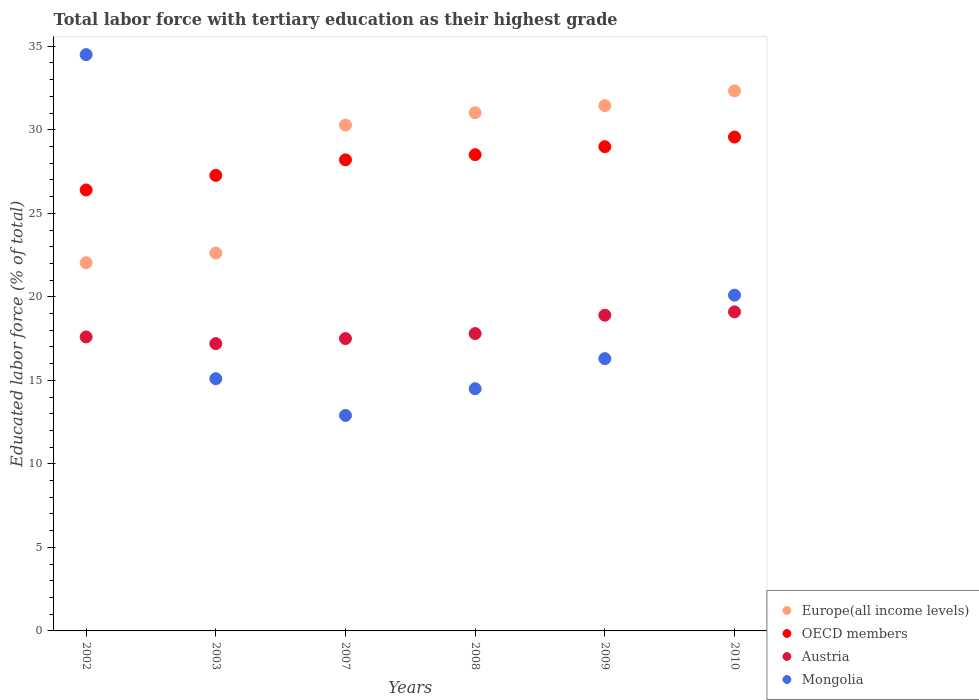What is the percentage of male labor force with tertiary education in Austria in 2002?
Ensure brevity in your answer.  17.6. Across all years, what is the maximum percentage of male labor force with tertiary education in OECD members?
Keep it short and to the point. 29.57. Across all years, what is the minimum percentage of male labor force with tertiary education in Europe(all income levels)?
Keep it short and to the point. 22.04. What is the total percentage of male labor force with tertiary education in Europe(all income levels) in the graph?
Give a very brief answer. 169.74. What is the difference between the percentage of male labor force with tertiary education in Europe(all income levels) in 2007 and that in 2008?
Your answer should be compact. -0.74. What is the difference between the percentage of male labor force with tertiary education in OECD members in 2003 and the percentage of male labor force with tertiary education in Europe(all income levels) in 2010?
Provide a short and direct response. -5.06. What is the average percentage of male labor force with tertiary education in Austria per year?
Offer a very short reply. 18.02. In the year 2003, what is the difference between the percentage of male labor force with tertiary education in OECD members and percentage of male labor force with tertiary education in Europe(all income levels)?
Ensure brevity in your answer.  4.65. In how many years, is the percentage of male labor force with tertiary education in Austria greater than 33 %?
Keep it short and to the point. 0. What is the ratio of the percentage of male labor force with tertiary education in OECD members in 2002 to that in 2009?
Provide a succinct answer. 0.91. Is the difference between the percentage of male labor force with tertiary education in OECD members in 2003 and 2008 greater than the difference between the percentage of male labor force with tertiary education in Europe(all income levels) in 2003 and 2008?
Provide a short and direct response. Yes. What is the difference between the highest and the second highest percentage of male labor force with tertiary education in OECD members?
Offer a terse response. 0.58. What is the difference between the highest and the lowest percentage of male labor force with tertiary education in Mongolia?
Offer a terse response. 21.6. Is the sum of the percentage of male labor force with tertiary education in Austria in 2003 and 2009 greater than the maximum percentage of male labor force with tertiary education in OECD members across all years?
Offer a very short reply. Yes. Is it the case that in every year, the sum of the percentage of male labor force with tertiary education in Europe(all income levels) and percentage of male labor force with tertiary education in Austria  is greater than the sum of percentage of male labor force with tertiary education in Mongolia and percentage of male labor force with tertiary education in OECD members?
Your answer should be compact. No. Is it the case that in every year, the sum of the percentage of male labor force with tertiary education in Austria and percentage of male labor force with tertiary education in Mongolia  is greater than the percentage of male labor force with tertiary education in Europe(all income levels)?
Offer a terse response. Yes. Does the percentage of male labor force with tertiary education in Austria monotonically increase over the years?
Provide a succinct answer. No. Is the percentage of male labor force with tertiary education in Europe(all income levels) strictly greater than the percentage of male labor force with tertiary education in Austria over the years?
Ensure brevity in your answer.  Yes. How many dotlines are there?
Offer a terse response. 4. What is the difference between two consecutive major ticks on the Y-axis?
Keep it short and to the point. 5. Does the graph contain grids?
Ensure brevity in your answer.  No. How are the legend labels stacked?
Ensure brevity in your answer.  Vertical. What is the title of the graph?
Make the answer very short. Total labor force with tertiary education as their highest grade. What is the label or title of the Y-axis?
Ensure brevity in your answer.  Educated labor force (% of total). What is the Educated labor force (% of total) of Europe(all income levels) in 2002?
Your answer should be very brief. 22.04. What is the Educated labor force (% of total) in OECD members in 2002?
Your answer should be compact. 26.4. What is the Educated labor force (% of total) in Austria in 2002?
Your response must be concise. 17.6. What is the Educated labor force (% of total) of Mongolia in 2002?
Your response must be concise. 34.5. What is the Educated labor force (% of total) in Europe(all income levels) in 2003?
Keep it short and to the point. 22.62. What is the Educated labor force (% of total) in OECD members in 2003?
Provide a succinct answer. 27.27. What is the Educated labor force (% of total) of Austria in 2003?
Make the answer very short. 17.2. What is the Educated labor force (% of total) of Mongolia in 2003?
Your answer should be very brief. 15.1. What is the Educated labor force (% of total) of Europe(all income levels) in 2007?
Ensure brevity in your answer.  30.28. What is the Educated labor force (% of total) of OECD members in 2007?
Your answer should be very brief. 28.2. What is the Educated labor force (% of total) of Mongolia in 2007?
Your answer should be compact. 12.9. What is the Educated labor force (% of total) of Europe(all income levels) in 2008?
Provide a succinct answer. 31.02. What is the Educated labor force (% of total) in OECD members in 2008?
Ensure brevity in your answer.  28.51. What is the Educated labor force (% of total) of Austria in 2008?
Make the answer very short. 17.8. What is the Educated labor force (% of total) of Mongolia in 2008?
Keep it short and to the point. 14.5. What is the Educated labor force (% of total) in Europe(all income levels) in 2009?
Offer a terse response. 31.45. What is the Educated labor force (% of total) of OECD members in 2009?
Provide a short and direct response. 28.99. What is the Educated labor force (% of total) in Austria in 2009?
Provide a short and direct response. 18.9. What is the Educated labor force (% of total) of Mongolia in 2009?
Your response must be concise. 16.3. What is the Educated labor force (% of total) of Europe(all income levels) in 2010?
Keep it short and to the point. 32.33. What is the Educated labor force (% of total) of OECD members in 2010?
Give a very brief answer. 29.57. What is the Educated labor force (% of total) of Austria in 2010?
Provide a short and direct response. 19.1. What is the Educated labor force (% of total) in Mongolia in 2010?
Your answer should be compact. 20.1. Across all years, what is the maximum Educated labor force (% of total) in Europe(all income levels)?
Your answer should be compact. 32.33. Across all years, what is the maximum Educated labor force (% of total) in OECD members?
Your answer should be compact. 29.57. Across all years, what is the maximum Educated labor force (% of total) in Austria?
Ensure brevity in your answer.  19.1. Across all years, what is the maximum Educated labor force (% of total) in Mongolia?
Ensure brevity in your answer.  34.5. Across all years, what is the minimum Educated labor force (% of total) of Europe(all income levels)?
Your response must be concise. 22.04. Across all years, what is the minimum Educated labor force (% of total) in OECD members?
Ensure brevity in your answer.  26.4. Across all years, what is the minimum Educated labor force (% of total) of Austria?
Offer a very short reply. 17.2. Across all years, what is the minimum Educated labor force (% of total) of Mongolia?
Provide a succinct answer. 12.9. What is the total Educated labor force (% of total) of Europe(all income levels) in the graph?
Your answer should be compact. 169.74. What is the total Educated labor force (% of total) of OECD members in the graph?
Provide a short and direct response. 168.93. What is the total Educated labor force (% of total) in Austria in the graph?
Provide a succinct answer. 108.1. What is the total Educated labor force (% of total) in Mongolia in the graph?
Give a very brief answer. 113.4. What is the difference between the Educated labor force (% of total) of Europe(all income levels) in 2002 and that in 2003?
Your answer should be compact. -0.58. What is the difference between the Educated labor force (% of total) in OECD members in 2002 and that in 2003?
Your answer should be compact. -0.87. What is the difference between the Educated labor force (% of total) of Europe(all income levels) in 2002 and that in 2007?
Your answer should be compact. -8.24. What is the difference between the Educated labor force (% of total) in OECD members in 2002 and that in 2007?
Ensure brevity in your answer.  -1.8. What is the difference between the Educated labor force (% of total) in Mongolia in 2002 and that in 2007?
Provide a short and direct response. 21.6. What is the difference between the Educated labor force (% of total) in Europe(all income levels) in 2002 and that in 2008?
Your response must be concise. -8.98. What is the difference between the Educated labor force (% of total) in OECD members in 2002 and that in 2008?
Your answer should be compact. -2.11. What is the difference between the Educated labor force (% of total) of Europe(all income levels) in 2002 and that in 2009?
Ensure brevity in your answer.  -9.4. What is the difference between the Educated labor force (% of total) in OECD members in 2002 and that in 2009?
Your answer should be very brief. -2.59. What is the difference between the Educated labor force (% of total) in Mongolia in 2002 and that in 2009?
Give a very brief answer. 18.2. What is the difference between the Educated labor force (% of total) of Europe(all income levels) in 2002 and that in 2010?
Provide a short and direct response. -10.28. What is the difference between the Educated labor force (% of total) of OECD members in 2002 and that in 2010?
Keep it short and to the point. -3.17. What is the difference between the Educated labor force (% of total) in Austria in 2002 and that in 2010?
Make the answer very short. -1.5. What is the difference between the Educated labor force (% of total) in Mongolia in 2002 and that in 2010?
Give a very brief answer. 14.4. What is the difference between the Educated labor force (% of total) of Europe(all income levels) in 2003 and that in 2007?
Provide a short and direct response. -7.66. What is the difference between the Educated labor force (% of total) in OECD members in 2003 and that in 2007?
Your answer should be very brief. -0.93. What is the difference between the Educated labor force (% of total) of Mongolia in 2003 and that in 2007?
Your answer should be compact. 2.2. What is the difference between the Educated labor force (% of total) of Europe(all income levels) in 2003 and that in 2008?
Give a very brief answer. -8.4. What is the difference between the Educated labor force (% of total) in OECD members in 2003 and that in 2008?
Give a very brief answer. -1.24. What is the difference between the Educated labor force (% of total) in Mongolia in 2003 and that in 2008?
Keep it short and to the point. 0.6. What is the difference between the Educated labor force (% of total) in Europe(all income levels) in 2003 and that in 2009?
Make the answer very short. -8.82. What is the difference between the Educated labor force (% of total) in OECD members in 2003 and that in 2009?
Your answer should be very brief. -1.72. What is the difference between the Educated labor force (% of total) in Austria in 2003 and that in 2009?
Offer a terse response. -1.7. What is the difference between the Educated labor force (% of total) in Mongolia in 2003 and that in 2009?
Keep it short and to the point. -1.2. What is the difference between the Educated labor force (% of total) in Europe(all income levels) in 2003 and that in 2010?
Keep it short and to the point. -9.7. What is the difference between the Educated labor force (% of total) in OECD members in 2003 and that in 2010?
Offer a terse response. -2.29. What is the difference between the Educated labor force (% of total) in Mongolia in 2003 and that in 2010?
Offer a very short reply. -5. What is the difference between the Educated labor force (% of total) of Europe(all income levels) in 2007 and that in 2008?
Provide a short and direct response. -0.74. What is the difference between the Educated labor force (% of total) of OECD members in 2007 and that in 2008?
Provide a short and direct response. -0.31. What is the difference between the Educated labor force (% of total) of Mongolia in 2007 and that in 2008?
Provide a succinct answer. -1.6. What is the difference between the Educated labor force (% of total) of Europe(all income levels) in 2007 and that in 2009?
Offer a terse response. -1.16. What is the difference between the Educated labor force (% of total) in OECD members in 2007 and that in 2009?
Keep it short and to the point. -0.79. What is the difference between the Educated labor force (% of total) of Austria in 2007 and that in 2009?
Provide a short and direct response. -1.4. What is the difference between the Educated labor force (% of total) in Mongolia in 2007 and that in 2009?
Your response must be concise. -3.4. What is the difference between the Educated labor force (% of total) in Europe(all income levels) in 2007 and that in 2010?
Your answer should be very brief. -2.04. What is the difference between the Educated labor force (% of total) of OECD members in 2007 and that in 2010?
Give a very brief answer. -1.36. What is the difference between the Educated labor force (% of total) of Europe(all income levels) in 2008 and that in 2009?
Offer a very short reply. -0.43. What is the difference between the Educated labor force (% of total) of OECD members in 2008 and that in 2009?
Your answer should be very brief. -0.48. What is the difference between the Educated labor force (% of total) of Mongolia in 2008 and that in 2009?
Keep it short and to the point. -1.8. What is the difference between the Educated labor force (% of total) in Europe(all income levels) in 2008 and that in 2010?
Your response must be concise. -1.31. What is the difference between the Educated labor force (% of total) in OECD members in 2008 and that in 2010?
Your answer should be compact. -1.06. What is the difference between the Educated labor force (% of total) of Europe(all income levels) in 2009 and that in 2010?
Your answer should be very brief. -0.88. What is the difference between the Educated labor force (% of total) in OECD members in 2009 and that in 2010?
Keep it short and to the point. -0.58. What is the difference between the Educated labor force (% of total) in Austria in 2009 and that in 2010?
Offer a very short reply. -0.2. What is the difference between the Educated labor force (% of total) in Europe(all income levels) in 2002 and the Educated labor force (% of total) in OECD members in 2003?
Provide a succinct answer. -5.23. What is the difference between the Educated labor force (% of total) in Europe(all income levels) in 2002 and the Educated labor force (% of total) in Austria in 2003?
Offer a terse response. 4.84. What is the difference between the Educated labor force (% of total) of Europe(all income levels) in 2002 and the Educated labor force (% of total) of Mongolia in 2003?
Give a very brief answer. 6.94. What is the difference between the Educated labor force (% of total) in OECD members in 2002 and the Educated labor force (% of total) in Austria in 2003?
Offer a very short reply. 9.2. What is the difference between the Educated labor force (% of total) of OECD members in 2002 and the Educated labor force (% of total) of Mongolia in 2003?
Provide a short and direct response. 11.3. What is the difference between the Educated labor force (% of total) in Europe(all income levels) in 2002 and the Educated labor force (% of total) in OECD members in 2007?
Your answer should be compact. -6.16. What is the difference between the Educated labor force (% of total) in Europe(all income levels) in 2002 and the Educated labor force (% of total) in Austria in 2007?
Provide a short and direct response. 4.54. What is the difference between the Educated labor force (% of total) in Europe(all income levels) in 2002 and the Educated labor force (% of total) in Mongolia in 2007?
Give a very brief answer. 9.14. What is the difference between the Educated labor force (% of total) in OECD members in 2002 and the Educated labor force (% of total) in Austria in 2007?
Make the answer very short. 8.9. What is the difference between the Educated labor force (% of total) in OECD members in 2002 and the Educated labor force (% of total) in Mongolia in 2007?
Give a very brief answer. 13.5. What is the difference between the Educated labor force (% of total) of Austria in 2002 and the Educated labor force (% of total) of Mongolia in 2007?
Keep it short and to the point. 4.7. What is the difference between the Educated labor force (% of total) of Europe(all income levels) in 2002 and the Educated labor force (% of total) of OECD members in 2008?
Provide a short and direct response. -6.47. What is the difference between the Educated labor force (% of total) of Europe(all income levels) in 2002 and the Educated labor force (% of total) of Austria in 2008?
Your answer should be very brief. 4.24. What is the difference between the Educated labor force (% of total) in Europe(all income levels) in 2002 and the Educated labor force (% of total) in Mongolia in 2008?
Ensure brevity in your answer.  7.54. What is the difference between the Educated labor force (% of total) in OECD members in 2002 and the Educated labor force (% of total) in Austria in 2008?
Your response must be concise. 8.6. What is the difference between the Educated labor force (% of total) of OECD members in 2002 and the Educated labor force (% of total) of Mongolia in 2008?
Keep it short and to the point. 11.9. What is the difference between the Educated labor force (% of total) in Europe(all income levels) in 2002 and the Educated labor force (% of total) in OECD members in 2009?
Provide a short and direct response. -6.95. What is the difference between the Educated labor force (% of total) of Europe(all income levels) in 2002 and the Educated labor force (% of total) of Austria in 2009?
Your answer should be very brief. 3.14. What is the difference between the Educated labor force (% of total) of Europe(all income levels) in 2002 and the Educated labor force (% of total) of Mongolia in 2009?
Your response must be concise. 5.74. What is the difference between the Educated labor force (% of total) of OECD members in 2002 and the Educated labor force (% of total) of Austria in 2009?
Keep it short and to the point. 7.5. What is the difference between the Educated labor force (% of total) in OECD members in 2002 and the Educated labor force (% of total) in Mongolia in 2009?
Make the answer very short. 10.1. What is the difference between the Educated labor force (% of total) of Austria in 2002 and the Educated labor force (% of total) of Mongolia in 2009?
Provide a succinct answer. 1.3. What is the difference between the Educated labor force (% of total) in Europe(all income levels) in 2002 and the Educated labor force (% of total) in OECD members in 2010?
Give a very brief answer. -7.52. What is the difference between the Educated labor force (% of total) in Europe(all income levels) in 2002 and the Educated labor force (% of total) in Austria in 2010?
Offer a very short reply. 2.94. What is the difference between the Educated labor force (% of total) in Europe(all income levels) in 2002 and the Educated labor force (% of total) in Mongolia in 2010?
Offer a terse response. 1.94. What is the difference between the Educated labor force (% of total) of OECD members in 2002 and the Educated labor force (% of total) of Austria in 2010?
Give a very brief answer. 7.3. What is the difference between the Educated labor force (% of total) of OECD members in 2002 and the Educated labor force (% of total) of Mongolia in 2010?
Your answer should be compact. 6.3. What is the difference between the Educated labor force (% of total) of Europe(all income levels) in 2003 and the Educated labor force (% of total) of OECD members in 2007?
Provide a succinct answer. -5.58. What is the difference between the Educated labor force (% of total) of Europe(all income levels) in 2003 and the Educated labor force (% of total) of Austria in 2007?
Your answer should be compact. 5.12. What is the difference between the Educated labor force (% of total) of Europe(all income levels) in 2003 and the Educated labor force (% of total) of Mongolia in 2007?
Keep it short and to the point. 9.72. What is the difference between the Educated labor force (% of total) in OECD members in 2003 and the Educated labor force (% of total) in Austria in 2007?
Your response must be concise. 9.77. What is the difference between the Educated labor force (% of total) of OECD members in 2003 and the Educated labor force (% of total) of Mongolia in 2007?
Provide a succinct answer. 14.37. What is the difference between the Educated labor force (% of total) in Europe(all income levels) in 2003 and the Educated labor force (% of total) in OECD members in 2008?
Your answer should be very brief. -5.89. What is the difference between the Educated labor force (% of total) of Europe(all income levels) in 2003 and the Educated labor force (% of total) of Austria in 2008?
Keep it short and to the point. 4.82. What is the difference between the Educated labor force (% of total) of Europe(all income levels) in 2003 and the Educated labor force (% of total) of Mongolia in 2008?
Provide a succinct answer. 8.12. What is the difference between the Educated labor force (% of total) of OECD members in 2003 and the Educated labor force (% of total) of Austria in 2008?
Offer a terse response. 9.47. What is the difference between the Educated labor force (% of total) of OECD members in 2003 and the Educated labor force (% of total) of Mongolia in 2008?
Provide a short and direct response. 12.77. What is the difference between the Educated labor force (% of total) of Europe(all income levels) in 2003 and the Educated labor force (% of total) of OECD members in 2009?
Offer a very short reply. -6.37. What is the difference between the Educated labor force (% of total) in Europe(all income levels) in 2003 and the Educated labor force (% of total) in Austria in 2009?
Your answer should be very brief. 3.72. What is the difference between the Educated labor force (% of total) in Europe(all income levels) in 2003 and the Educated labor force (% of total) in Mongolia in 2009?
Your answer should be very brief. 6.32. What is the difference between the Educated labor force (% of total) in OECD members in 2003 and the Educated labor force (% of total) in Austria in 2009?
Ensure brevity in your answer.  8.37. What is the difference between the Educated labor force (% of total) in OECD members in 2003 and the Educated labor force (% of total) in Mongolia in 2009?
Ensure brevity in your answer.  10.97. What is the difference between the Educated labor force (% of total) in Europe(all income levels) in 2003 and the Educated labor force (% of total) in OECD members in 2010?
Your answer should be very brief. -6.94. What is the difference between the Educated labor force (% of total) in Europe(all income levels) in 2003 and the Educated labor force (% of total) in Austria in 2010?
Make the answer very short. 3.52. What is the difference between the Educated labor force (% of total) of Europe(all income levels) in 2003 and the Educated labor force (% of total) of Mongolia in 2010?
Keep it short and to the point. 2.52. What is the difference between the Educated labor force (% of total) of OECD members in 2003 and the Educated labor force (% of total) of Austria in 2010?
Your answer should be very brief. 8.17. What is the difference between the Educated labor force (% of total) of OECD members in 2003 and the Educated labor force (% of total) of Mongolia in 2010?
Your answer should be very brief. 7.17. What is the difference between the Educated labor force (% of total) of Austria in 2003 and the Educated labor force (% of total) of Mongolia in 2010?
Keep it short and to the point. -2.9. What is the difference between the Educated labor force (% of total) in Europe(all income levels) in 2007 and the Educated labor force (% of total) in OECD members in 2008?
Provide a short and direct response. 1.77. What is the difference between the Educated labor force (% of total) of Europe(all income levels) in 2007 and the Educated labor force (% of total) of Austria in 2008?
Your answer should be very brief. 12.48. What is the difference between the Educated labor force (% of total) in Europe(all income levels) in 2007 and the Educated labor force (% of total) in Mongolia in 2008?
Ensure brevity in your answer.  15.78. What is the difference between the Educated labor force (% of total) in OECD members in 2007 and the Educated labor force (% of total) in Austria in 2008?
Ensure brevity in your answer.  10.4. What is the difference between the Educated labor force (% of total) in OECD members in 2007 and the Educated labor force (% of total) in Mongolia in 2008?
Your answer should be compact. 13.7. What is the difference between the Educated labor force (% of total) in Austria in 2007 and the Educated labor force (% of total) in Mongolia in 2008?
Your response must be concise. 3. What is the difference between the Educated labor force (% of total) in Europe(all income levels) in 2007 and the Educated labor force (% of total) in OECD members in 2009?
Your answer should be very brief. 1.29. What is the difference between the Educated labor force (% of total) of Europe(all income levels) in 2007 and the Educated labor force (% of total) of Austria in 2009?
Ensure brevity in your answer.  11.38. What is the difference between the Educated labor force (% of total) of Europe(all income levels) in 2007 and the Educated labor force (% of total) of Mongolia in 2009?
Give a very brief answer. 13.98. What is the difference between the Educated labor force (% of total) of OECD members in 2007 and the Educated labor force (% of total) of Austria in 2009?
Make the answer very short. 9.3. What is the difference between the Educated labor force (% of total) of OECD members in 2007 and the Educated labor force (% of total) of Mongolia in 2009?
Give a very brief answer. 11.9. What is the difference between the Educated labor force (% of total) of Austria in 2007 and the Educated labor force (% of total) of Mongolia in 2009?
Offer a very short reply. 1.2. What is the difference between the Educated labor force (% of total) of Europe(all income levels) in 2007 and the Educated labor force (% of total) of OECD members in 2010?
Keep it short and to the point. 0.72. What is the difference between the Educated labor force (% of total) of Europe(all income levels) in 2007 and the Educated labor force (% of total) of Austria in 2010?
Keep it short and to the point. 11.18. What is the difference between the Educated labor force (% of total) in Europe(all income levels) in 2007 and the Educated labor force (% of total) in Mongolia in 2010?
Provide a short and direct response. 10.18. What is the difference between the Educated labor force (% of total) of OECD members in 2007 and the Educated labor force (% of total) of Austria in 2010?
Provide a succinct answer. 9.1. What is the difference between the Educated labor force (% of total) in OECD members in 2007 and the Educated labor force (% of total) in Mongolia in 2010?
Provide a short and direct response. 8.1. What is the difference between the Educated labor force (% of total) in Europe(all income levels) in 2008 and the Educated labor force (% of total) in OECD members in 2009?
Provide a succinct answer. 2.03. What is the difference between the Educated labor force (% of total) of Europe(all income levels) in 2008 and the Educated labor force (% of total) of Austria in 2009?
Your answer should be compact. 12.12. What is the difference between the Educated labor force (% of total) in Europe(all income levels) in 2008 and the Educated labor force (% of total) in Mongolia in 2009?
Provide a short and direct response. 14.72. What is the difference between the Educated labor force (% of total) of OECD members in 2008 and the Educated labor force (% of total) of Austria in 2009?
Give a very brief answer. 9.61. What is the difference between the Educated labor force (% of total) in OECD members in 2008 and the Educated labor force (% of total) in Mongolia in 2009?
Your answer should be very brief. 12.21. What is the difference between the Educated labor force (% of total) in Europe(all income levels) in 2008 and the Educated labor force (% of total) in OECD members in 2010?
Make the answer very short. 1.45. What is the difference between the Educated labor force (% of total) of Europe(all income levels) in 2008 and the Educated labor force (% of total) of Austria in 2010?
Ensure brevity in your answer.  11.92. What is the difference between the Educated labor force (% of total) in Europe(all income levels) in 2008 and the Educated labor force (% of total) in Mongolia in 2010?
Your answer should be compact. 10.92. What is the difference between the Educated labor force (% of total) in OECD members in 2008 and the Educated labor force (% of total) in Austria in 2010?
Provide a short and direct response. 9.41. What is the difference between the Educated labor force (% of total) in OECD members in 2008 and the Educated labor force (% of total) in Mongolia in 2010?
Offer a terse response. 8.41. What is the difference between the Educated labor force (% of total) in Austria in 2008 and the Educated labor force (% of total) in Mongolia in 2010?
Make the answer very short. -2.3. What is the difference between the Educated labor force (% of total) in Europe(all income levels) in 2009 and the Educated labor force (% of total) in OECD members in 2010?
Offer a terse response. 1.88. What is the difference between the Educated labor force (% of total) of Europe(all income levels) in 2009 and the Educated labor force (% of total) of Austria in 2010?
Give a very brief answer. 12.35. What is the difference between the Educated labor force (% of total) of Europe(all income levels) in 2009 and the Educated labor force (% of total) of Mongolia in 2010?
Offer a very short reply. 11.35. What is the difference between the Educated labor force (% of total) in OECD members in 2009 and the Educated labor force (% of total) in Austria in 2010?
Keep it short and to the point. 9.89. What is the difference between the Educated labor force (% of total) in OECD members in 2009 and the Educated labor force (% of total) in Mongolia in 2010?
Offer a very short reply. 8.89. What is the difference between the Educated labor force (% of total) of Austria in 2009 and the Educated labor force (% of total) of Mongolia in 2010?
Provide a short and direct response. -1.2. What is the average Educated labor force (% of total) of Europe(all income levels) per year?
Provide a succinct answer. 28.29. What is the average Educated labor force (% of total) of OECD members per year?
Offer a very short reply. 28.16. What is the average Educated labor force (% of total) of Austria per year?
Offer a terse response. 18.02. What is the average Educated labor force (% of total) of Mongolia per year?
Provide a succinct answer. 18.9. In the year 2002, what is the difference between the Educated labor force (% of total) of Europe(all income levels) and Educated labor force (% of total) of OECD members?
Provide a succinct answer. -4.35. In the year 2002, what is the difference between the Educated labor force (% of total) of Europe(all income levels) and Educated labor force (% of total) of Austria?
Your answer should be very brief. 4.44. In the year 2002, what is the difference between the Educated labor force (% of total) in Europe(all income levels) and Educated labor force (% of total) in Mongolia?
Ensure brevity in your answer.  -12.46. In the year 2002, what is the difference between the Educated labor force (% of total) of OECD members and Educated labor force (% of total) of Austria?
Your response must be concise. 8.8. In the year 2002, what is the difference between the Educated labor force (% of total) in OECD members and Educated labor force (% of total) in Mongolia?
Your answer should be very brief. -8.1. In the year 2002, what is the difference between the Educated labor force (% of total) in Austria and Educated labor force (% of total) in Mongolia?
Your answer should be very brief. -16.9. In the year 2003, what is the difference between the Educated labor force (% of total) of Europe(all income levels) and Educated labor force (% of total) of OECD members?
Offer a terse response. -4.65. In the year 2003, what is the difference between the Educated labor force (% of total) in Europe(all income levels) and Educated labor force (% of total) in Austria?
Your answer should be compact. 5.42. In the year 2003, what is the difference between the Educated labor force (% of total) of Europe(all income levels) and Educated labor force (% of total) of Mongolia?
Your answer should be compact. 7.52. In the year 2003, what is the difference between the Educated labor force (% of total) of OECD members and Educated labor force (% of total) of Austria?
Your answer should be very brief. 10.07. In the year 2003, what is the difference between the Educated labor force (% of total) of OECD members and Educated labor force (% of total) of Mongolia?
Provide a succinct answer. 12.17. In the year 2003, what is the difference between the Educated labor force (% of total) of Austria and Educated labor force (% of total) of Mongolia?
Your answer should be compact. 2.1. In the year 2007, what is the difference between the Educated labor force (% of total) in Europe(all income levels) and Educated labor force (% of total) in OECD members?
Your answer should be compact. 2.08. In the year 2007, what is the difference between the Educated labor force (% of total) in Europe(all income levels) and Educated labor force (% of total) in Austria?
Provide a short and direct response. 12.78. In the year 2007, what is the difference between the Educated labor force (% of total) in Europe(all income levels) and Educated labor force (% of total) in Mongolia?
Give a very brief answer. 17.38. In the year 2007, what is the difference between the Educated labor force (% of total) in OECD members and Educated labor force (% of total) in Austria?
Offer a very short reply. 10.7. In the year 2007, what is the difference between the Educated labor force (% of total) in OECD members and Educated labor force (% of total) in Mongolia?
Give a very brief answer. 15.3. In the year 2007, what is the difference between the Educated labor force (% of total) of Austria and Educated labor force (% of total) of Mongolia?
Provide a short and direct response. 4.6. In the year 2008, what is the difference between the Educated labor force (% of total) of Europe(all income levels) and Educated labor force (% of total) of OECD members?
Make the answer very short. 2.51. In the year 2008, what is the difference between the Educated labor force (% of total) in Europe(all income levels) and Educated labor force (% of total) in Austria?
Ensure brevity in your answer.  13.22. In the year 2008, what is the difference between the Educated labor force (% of total) in Europe(all income levels) and Educated labor force (% of total) in Mongolia?
Provide a short and direct response. 16.52. In the year 2008, what is the difference between the Educated labor force (% of total) in OECD members and Educated labor force (% of total) in Austria?
Your response must be concise. 10.71. In the year 2008, what is the difference between the Educated labor force (% of total) of OECD members and Educated labor force (% of total) of Mongolia?
Offer a terse response. 14.01. In the year 2009, what is the difference between the Educated labor force (% of total) of Europe(all income levels) and Educated labor force (% of total) of OECD members?
Your response must be concise. 2.46. In the year 2009, what is the difference between the Educated labor force (% of total) of Europe(all income levels) and Educated labor force (% of total) of Austria?
Make the answer very short. 12.55. In the year 2009, what is the difference between the Educated labor force (% of total) of Europe(all income levels) and Educated labor force (% of total) of Mongolia?
Offer a very short reply. 15.15. In the year 2009, what is the difference between the Educated labor force (% of total) in OECD members and Educated labor force (% of total) in Austria?
Provide a short and direct response. 10.09. In the year 2009, what is the difference between the Educated labor force (% of total) of OECD members and Educated labor force (% of total) of Mongolia?
Your answer should be very brief. 12.69. In the year 2009, what is the difference between the Educated labor force (% of total) in Austria and Educated labor force (% of total) in Mongolia?
Keep it short and to the point. 2.6. In the year 2010, what is the difference between the Educated labor force (% of total) of Europe(all income levels) and Educated labor force (% of total) of OECD members?
Your answer should be compact. 2.76. In the year 2010, what is the difference between the Educated labor force (% of total) of Europe(all income levels) and Educated labor force (% of total) of Austria?
Offer a terse response. 13.23. In the year 2010, what is the difference between the Educated labor force (% of total) in Europe(all income levels) and Educated labor force (% of total) in Mongolia?
Your response must be concise. 12.23. In the year 2010, what is the difference between the Educated labor force (% of total) of OECD members and Educated labor force (% of total) of Austria?
Give a very brief answer. 10.47. In the year 2010, what is the difference between the Educated labor force (% of total) of OECD members and Educated labor force (% of total) of Mongolia?
Provide a succinct answer. 9.47. What is the ratio of the Educated labor force (% of total) of Europe(all income levels) in 2002 to that in 2003?
Keep it short and to the point. 0.97. What is the ratio of the Educated labor force (% of total) in OECD members in 2002 to that in 2003?
Your answer should be compact. 0.97. What is the ratio of the Educated labor force (% of total) in Austria in 2002 to that in 2003?
Provide a succinct answer. 1.02. What is the ratio of the Educated labor force (% of total) of Mongolia in 2002 to that in 2003?
Your answer should be compact. 2.28. What is the ratio of the Educated labor force (% of total) in Europe(all income levels) in 2002 to that in 2007?
Offer a terse response. 0.73. What is the ratio of the Educated labor force (% of total) of OECD members in 2002 to that in 2007?
Give a very brief answer. 0.94. What is the ratio of the Educated labor force (% of total) in Austria in 2002 to that in 2007?
Provide a succinct answer. 1.01. What is the ratio of the Educated labor force (% of total) of Mongolia in 2002 to that in 2007?
Keep it short and to the point. 2.67. What is the ratio of the Educated labor force (% of total) of Europe(all income levels) in 2002 to that in 2008?
Provide a short and direct response. 0.71. What is the ratio of the Educated labor force (% of total) of OECD members in 2002 to that in 2008?
Your answer should be very brief. 0.93. What is the ratio of the Educated labor force (% of total) of Austria in 2002 to that in 2008?
Make the answer very short. 0.99. What is the ratio of the Educated labor force (% of total) of Mongolia in 2002 to that in 2008?
Your response must be concise. 2.38. What is the ratio of the Educated labor force (% of total) of Europe(all income levels) in 2002 to that in 2009?
Ensure brevity in your answer.  0.7. What is the ratio of the Educated labor force (% of total) in OECD members in 2002 to that in 2009?
Give a very brief answer. 0.91. What is the ratio of the Educated labor force (% of total) of Austria in 2002 to that in 2009?
Offer a very short reply. 0.93. What is the ratio of the Educated labor force (% of total) of Mongolia in 2002 to that in 2009?
Give a very brief answer. 2.12. What is the ratio of the Educated labor force (% of total) in Europe(all income levels) in 2002 to that in 2010?
Provide a succinct answer. 0.68. What is the ratio of the Educated labor force (% of total) in OECD members in 2002 to that in 2010?
Your answer should be compact. 0.89. What is the ratio of the Educated labor force (% of total) in Austria in 2002 to that in 2010?
Offer a very short reply. 0.92. What is the ratio of the Educated labor force (% of total) of Mongolia in 2002 to that in 2010?
Your answer should be compact. 1.72. What is the ratio of the Educated labor force (% of total) in Europe(all income levels) in 2003 to that in 2007?
Provide a succinct answer. 0.75. What is the ratio of the Educated labor force (% of total) in Austria in 2003 to that in 2007?
Provide a short and direct response. 0.98. What is the ratio of the Educated labor force (% of total) of Mongolia in 2003 to that in 2007?
Your response must be concise. 1.17. What is the ratio of the Educated labor force (% of total) in Europe(all income levels) in 2003 to that in 2008?
Ensure brevity in your answer.  0.73. What is the ratio of the Educated labor force (% of total) in OECD members in 2003 to that in 2008?
Keep it short and to the point. 0.96. What is the ratio of the Educated labor force (% of total) in Austria in 2003 to that in 2008?
Your response must be concise. 0.97. What is the ratio of the Educated labor force (% of total) in Mongolia in 2003 to that in 2008?
Ensure brevity in your answer.  1.04. What is the ratio of the Educated labor force (% of total) in Europe(all income levels) in 2003 to that in 2009?
Offer a very short reply. 0.72. What is the ratio of the Educated labor force (% of total) in OECD members in 2003 to that in 2009?
Offer a terse response. 0.94. What is the ratio of the Educated labor force (% of total) of Austria in 2003 to that in 2009?
Your answer should be compact. 0.91. What is the ratio of the Educated labor force (% of total) of Mongolia in 2003 to that in 2009?
Your response must be concise. 0.93. What is the ratio of the Educated labor force (% of total) in Europe(all income levels) in 2003 to that in 2010?
Make the answer very short. 0.7. What is the ratio of the Educated labor force (% of total) of OECD members in 2003 to that in 2010?
Provide a short and direct response. 0.92. What is the ratio of the Educated labor force (% of total) of Austria in 2003 to that in 2010?
Ensure brevity in your answer.  0.9. What is the ratio of the Educated labor force (% of total) of Mongolia in 2003 to that in 2010?
Ensure brevity in your answer.  0.75. What is the ratio of the Educated labor force (% of total) in Europe(all income levels) in 2007 to that in 2008?
Make the answer very short. 0.98. What is the ratio of the Educated labor force (% of total) of Austria in 2007 to that in 2008?
Your answer should be compact. 0.98. What is the ratio of the Educated labor force (% of total) of Mongolia in 2007 to that in 2008?
Your answer should be compact. 0.89. What is the ratio of the Educated labor force (% of total) of OECD members in 2007 to that in 2009?
Offer a terse response. 0.97. What is the ratio of the Educated labor force (% of total) in Austria in 2007 to that in 2009?
Make the answer very short. 0.93. What is the ratio of the Educated labor force (% of total) in Mongolia in 2007 to that in 2009?
Make the answer very short. 0.79. What is the ratio of the Educated labor force (% of total) in Europe(all income levels) in 2007 to that in 2010?
Keep it short and to the point. 0.94. What is the ratio of the Educated labor force (% of total) of OECD members in 2007 to that in 2010?
Your answer should be compact. 0.95. What is the ratio of the Educated labor force (% of total) of Austria in 2007 to that in 2010?
Provide a succinct answer. 0.92. What is the ratio of the Educated labor force (% of total) in Mongolia in 2007 to that in 2010?
Your response must be concise. 0.64. What is the ratio of the Educated labor force (% of total) of Europe(all income levels) in 2008 to that in 2009?
Provide a succinct answer. 0.99. What is the ratio of the Educated labor force (% of total) in OECD members in 2008 to that in 2009?
Your answer should be compact. 0.98. What is the ratio of the Educated labor force (% of total) in Austria in 2008 to that in 2009?
Offer a terse response. 0.94. What is the ratio of the Educated labor force (% of total) in Mongolia in 2008 to that in 2009?
Provide a succinct answer. 0.89. What is the ratio of the Educated labor force (% of total) in Europe(all income levels) in 2008 to that in 2010?
Offer a terse response. 0.96. What is the ratio of the Educated labor force (% of total) of Austria in 2008 to that in 2010?
Give a very brief answer. 0.93. What is the ratio of the Educated labor force (% of total) of Mongolia in 2008 to that in 2010?
Your answer should be compact. 0.72. What is the ratio of the Educated labor force (% of total) in Europe(all income levels) in 2009 to that in 2010?
Your answer should be very brief. 0.97. What is the ratio of the Educated labor force (% of total) of OECD members in 2009 to that in 2010?
Your answer should be very brief. 0.98. What is the ratio of the Educated labor force (% of total) of Austria in 2009 to that in 2010?
Keep it short and to the point. 0.99. What is the ratio of the Educated labor force (% of total) of Mongolia in 2009 to that in 2010?
Provide a short and direct response. 0.81. What is the difference between the highest and the second highest Educated labor force (% of total) in Europe(all income levels)?
Keep it short and to the point. 0.88. What is the difference between the highest and the second highest Educated labor force (% of total) in OECD members?
Keep it short and to the point. 0.58. What is the difference between the highest and the second highest Educated labor force (% of total) of Austria?
Ensure brevity in your answer.  0.2. What is the difference between the highest and the lowest Educated labor force (% of total) of Europe(all income levels)?
Offer a terse response. 10.28. What is the difference between the highest and the lowest Educated labor force (% of total) in OECD members?
Your answer should be very brief. 3.17. What is the difference between the highest and the lowest Educated labor force (% of total) in Austria?
Provide a short and direct response. 1.9. What is the difference between the highest and the lowest Educated labor force (% of total) in Mongolia?
Give a very brief answer. 21.6. 